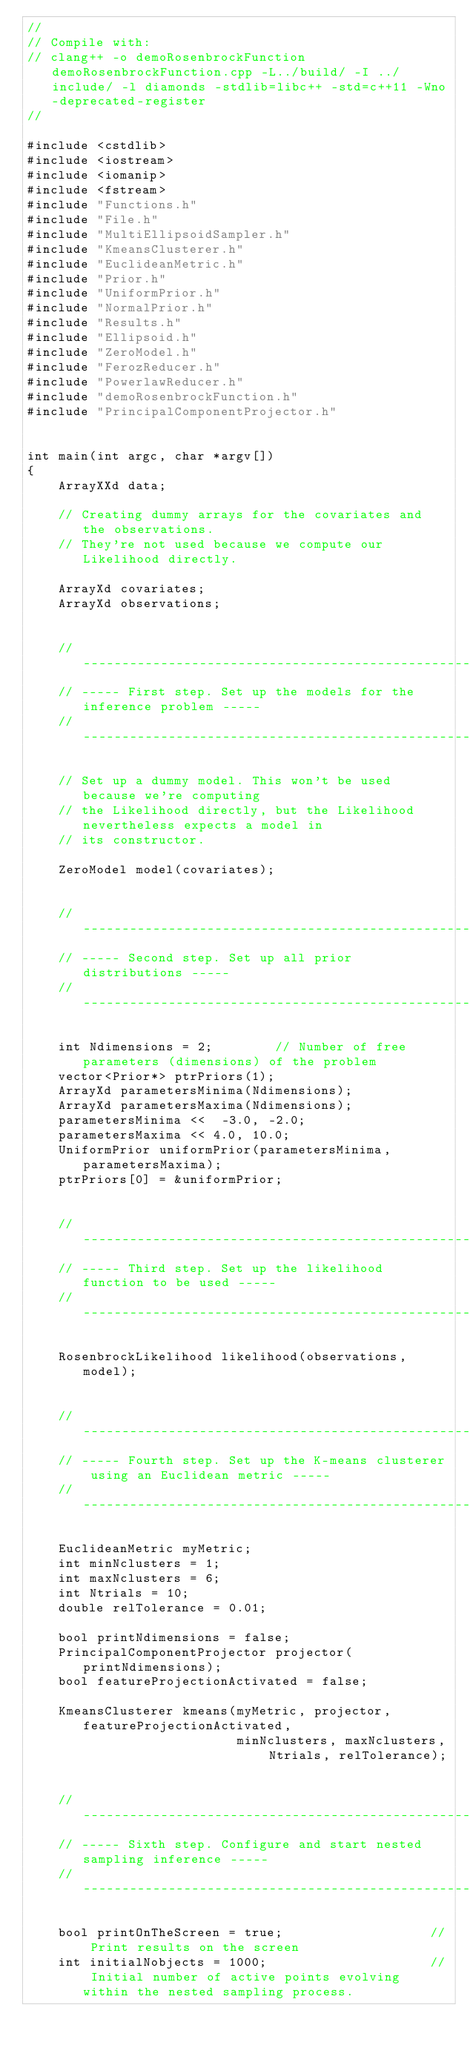Convert code to text. <code><loc_0><loc_0><loc_500><loc_500><_C++_>//
// Compile with: 
// clang++ -o demoRosenbrockFunction demoRosenbrockFunction.cpp -L../build/ -I ../include/ -l diamonds -stdlib=libc++ -std=c++11 -Wno-deprecated-register
// 

#include <cstdlib>
#include <iostream>
#include <iomanip>
#include <fstream>
#include "Functions.h"
#include "File.h"
#include "MultiEllipsoidSampler.h"
#include "KmeansClusterer.h"
#include "EuclideanMetric.h"
#include "Prior.h"
#include "UniformPrior.h"
#include "NormalPrior.h"
#include "Results.h"
#include "Ellipsoid.h"
#include "ZeroModel.h"
#include "FerozReducer.h"
#include "PowerlawReducer.h"
#include "demoRosenbrockFunction.h"
#include "PrincipalComponentProjector.h"


int main(int argc, char *argv[])
{
    ArrayXXd data;
  
    // Creating dummy arrays for the covariates and the observations.
    // They're not used because we compute our Likelihood directly. 

    ArrayXd covariates;
    ArrayXd observations;


    // -------------------------------------------------------------------
    // ----- First step. Set up the models for the inference problem ----- 
    // ------------------------------------------------------------------- 

    // Set up a dummy model. This won't be used because we're computing
    // the Likelihood directly, but the Likelihood nevertheless expects a model in 
    // its constructor.
    
    ZeroModel model(covariates);


    // -------------------------------------------------------
    // ----- Second step. Set up all prior distributions -----
    // -------------------------------------------------------

    int Ndimensions = 2;        // Number of free parameters (dimensions) of the problem
    vector<Prior*> ptrPriors(1);
    ArrayXd parametersMinima(Ndimensions);
    ArrayXd parametersMaxima(Ndimensions);
    parametersMinima <<  -3.0, -2.0;
    parametersMaxima << 4.0, 10.0;
    UniformPrior uniformPrior(parametersMinima, parametersMaxima);
    ptrPriors[0] = &uniformPrior;   


    // -----------------------------------------------------------------
    // ----- Third step. Set up the likelihood function to be used -----
    // -----------------------------------------------------------------

    RosenbrockLikelihood likelihood(observations, model);
    

    // -------------------------------------------------------------------------------
    // ----- Fourth step. Set up the K-means clusterer using an Euclidean metric -----
    // -------------------------------------------------------------------------------

    EuclideanMetric myMetric;
    int minNclusters = 1;
    int maxNclusters = 6;
    int Ntrials = 10;
    double relTolerance = 0.01;

    bool printNdimensions = false;
    PrincipalComponentProjector projector(printNdimensions);
    bool featureProjectionActivated = false;

    KmeansClusterer kmeans(myMetric, projector, featureProjectionActivated, 
                           minNclusters, maxNclusters, Ntrials, relTolerance); 


    // ---------------------------------------------------------------------
    // ----- Sixth step. Configure and start nested sampling inference -----
    // ---------------------------------------------------------------------
    
    bool printOnTheScreen = true;                   // Print results on the screen
    int initialNobjects = 1000;                     // Initial number of active points evolving within the nested sampling process.</code> 